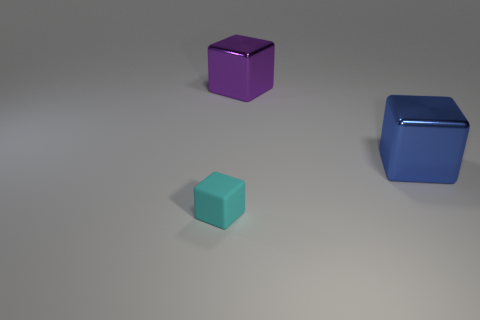Subtract all purple blocks. How many blocks are left? 2 Add 3 cyan rubber balls. How many objects exist? 6 Subtract all blue cubes. How many cubes are left? 2 Subtract 2 cubes. How many cubes are left? 1 Add 3 tiny cyan things. How many tiny cyan things are left? 4 Add 2 cyan rubber blocks. How many cyan rubber blocks exist? 3 Subtract 0 brown cylinders. How many objects are left? 3 Subtract all red blocks. Subtract all red balls. How many blocks are left? 3 Subtract all tiny cubes. Subtract all metal blocks. How many objects are left? 0 